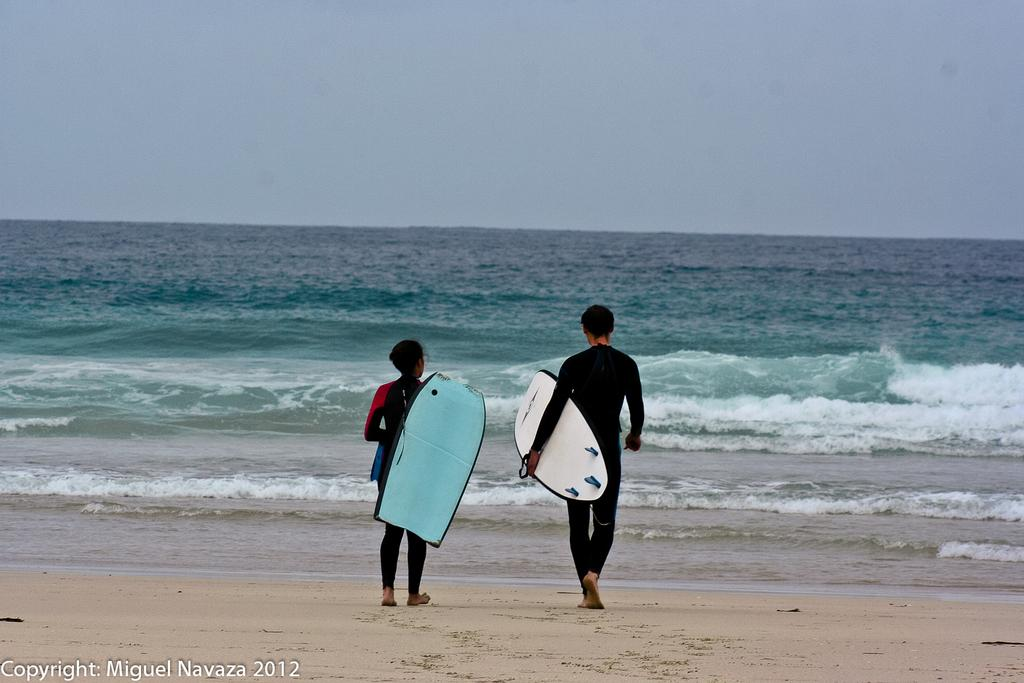Who is present in the image? There is a man and a woman in the image. What are they holding? Both the man and the woman are holding surfing boards. What are they doing in the image? They are walking into the sea. What can be seen in the background of the image? There is a sky visible in the background of the image. What type of surface is under their feet? There is sand on the floor in the image. What is the effect of the skate on the man's surfing skills in the image? There is no skate present in the image, so its effect on the man's surfing skills cannot be determined. 